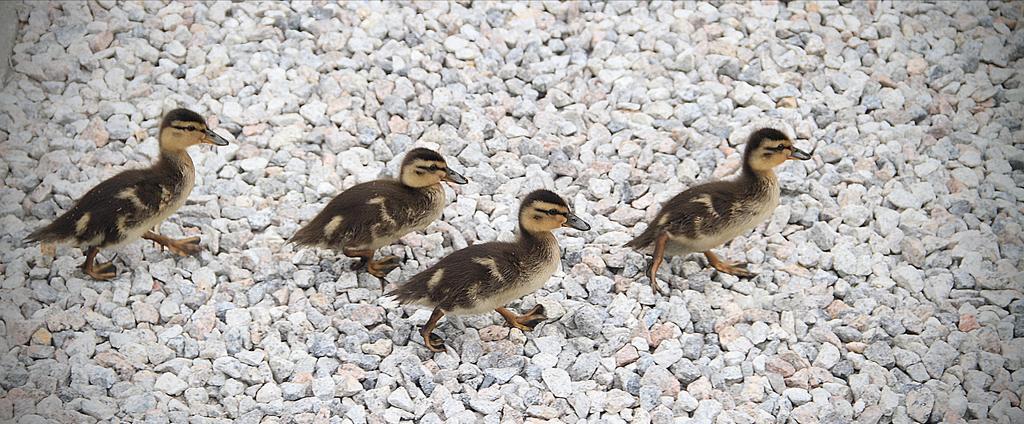In one or two sentences, can you explain what this image depicts? In this image I see 4 birds, in which all of them are of brown and cream in color and I see number of stones. 